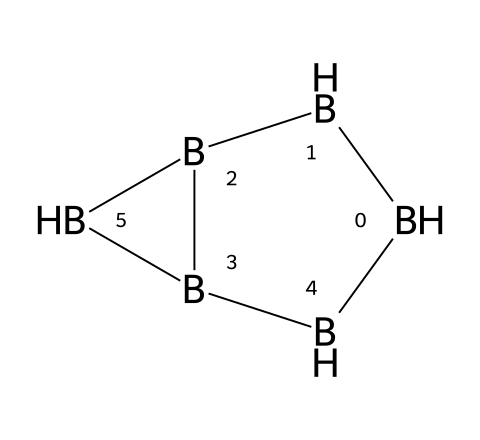How many boron atoms are present in pentaborane? The name "pentaborane" indicates that there are five boron atoms in the structure. Numerically, "penta-" refers to the number five.
Answer: five What is the total number of hydrogen atoms in the structural formula? The pentaborane (B5H11) consists of 11 hydrogen atoms as per its molecular formula. This information can be determined from the known stoichiometry of this compound.
Answer: eleven What type of bonding is primarily present in boranes like pentaborane? Boranes, including pentaborane, primarily exhibit covalent bonding characterized by the sharing of electrons between boron and hydrogen atoms. This can be inferred from their structural representation.
Answer: covalent Is pentaborane a stable or highly reactive compound? Pentaborane is known to be a highly reactive compound, which is highlighted by its potential applications as a fuel due to reactivity.
Answer: highly reactive What potential application is associated with pentaborane? Pentaborane has potential applications as a fuel, known for its high reactivity and energy content, which makes it viable for energy release in various reactions.
Answer: fuel Can pentaborane undergo combustion reactions? Yes, pentaborane can undergo combustion, releasing energy and products like boron oxides and water, which is typical for boranes when they react with oxygen.
Answer: yes 